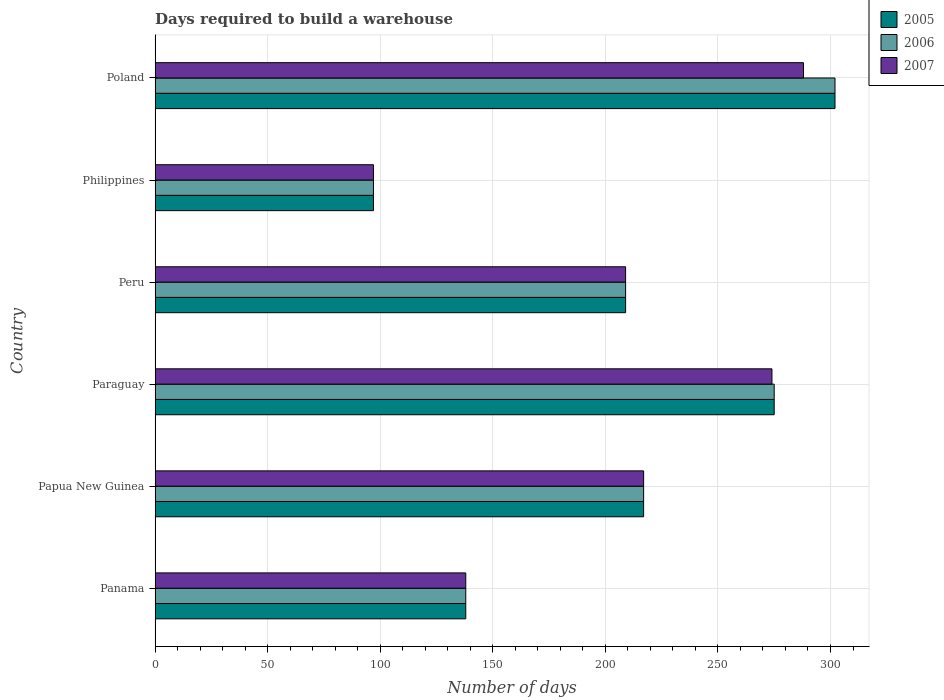How many groups of bars are there?
Your response must be concise. 6. Are the number of bars per tick equal to the number of legend labels?
Provide a short and direct response. Yes. How many bars are there on the 1st tick from the top?
Your response must be concise. 3. How many bars are there on the 4th tick from the bottom?
Keep it short and to the point. 3. In how many cases, is the number of bars for a given country not equal to the number of legend labels?
Provide a succinct answer. 0. What is the days required to build a warehouse in in 2005 in Paraguay?
Provide a short and direct response. 275. Across all countries, what is the maximum days required to build a warehouse in in 2005?
Provide a short and direct response. 302. Across all countries, what is the minimum days required to build a warehouse in in 2005?
Offer a terse response. 97. What is the total days required to build a warehouse in in 2005 in the graph?
Provide a succinct answer. 1238. What is the difference between the days required to build a warehouse in in 2006 in Papua New Guinea and that in Philippines?
Provide a succinct answer. 120. What is the difference between the days required to build a warehouse in in 2007 in Papua New Guinea and the days required to build a warehouse in in 2005 in Paraguay?
Make the answer very short. -58. What is the average days required to build a warehouse in in 2006 per country?
Offer a terse response. 206.33. What is the ratio of the days required to build a warehouse in in 2007 in Panama to that in Papua New Guinea?
Your answer should be very brief. 0.64. Is the days required to build a warehouse in in 2005 in Paraguay less than that in Philippines?
Provide a short and direct response. No. Is the difference between the days required to build a warehouse in in 2007 in Paraguay and Poland greater than the difference between the days required to build a warehouse in in 2006 in Paraguay and Poland?
Offer a very short reply. Yes. What is the difference between the highest and the second highest days required to build a warehouse in in 2007?
Ensure brevity in your answer.  14. What is the difference between the highest and the lowest days required to build a warehouse in in 2006?
Ensure brevity in your answer.  205. In how many countries, is the days required to build a warehouse in in 2005 greater than the average days required to build a warehouse in in 2005 taken over all countries?
Your response must be concise. 4. What does the 3rd bar from the top in Peru represents?
Your answer should be very brief. 2005. How many bars are there?
Give a very brief answer. 18. How many countries are there in the graph?
Offer a terse response. 6. What is the difference between two consecutive major ticks on the X-axis?
Give a very brief answer. 50. Does the graph contain any zero values?
Offer a terse response. No. Where does the legend appear in the graph?
Offer a terse response. Top right. What is the title of the graph?
Provide a short and direct response. Days required to build a warehouse. Does "1982" appear as one of the legend labels in the graph?
Your answer should be very brief. No. What is the label or title of the X-axis?
Offer a very short reply. Number of days. What is the label or title of the Y-axis?
Offer a very short reply. Country. What is the Number of days in 2005 in Panama?
Keep it short and to the point. 138. What is the Number of days in 2006 in Panama?
Make the answer very short. 138. What is the Number of days in 2007 in Panama?
Your answer should be compact. 138. What is the Number of days of 2005 in Papua New Guinea?
Your answer should be compact. 217. What is the Number of days in 2006 in Papua New Guinea?
Your answer should be compact. 217. What is the Number of days in 2007 in Papua New Guinea?
Provide a short and direct response. 217. What is the Number of days in 2005 in Paraguay?
Provide a short and direct response. 275. What is the Number of days of 2006 in Paraguay?
Make the answer very short. 275. What is the Number of days in 2007 in Paraguay?
Keep it short and to the point. 274. What is the Number of days in 2005 in Peru?
Your response must be concise. 209. What is the Number of days of 2006 in Peru?
Your answer should be very brief. 209. What is the Number of days of 2007 in Peru?
Offer a terse response. 209. What is the Number of days of 2005 in Philippines?
Your response must be concise. 97. What is the Number of days in 2006 in Philippines?
Make the answer very short. 97. What is the Number of days of 2007 in Philippines?
Your answer should be very brief. 97. What is the Number of days in 2005 in Poland?
Ensure brevity in your answer.  302. What is the Number of days of 2006 in Poland?
Give a very brief answer. 302. What is the Number of days of 2007 in Poland?
Offer a terse response. 288. Across all countries, what is the maximum Number of days in 2005?
Offer a terse response. 302. Across all countries, what is the maximum Number of days in 2006?
Keep it short and to the point. 302. Across all countries, what is the maximum Number of days of 2007?
Your answer should be compact. 288. Across all countries, what is the minimum Number of days of 2005?
Keep it short and to the point. 97. Across all countries, what is the minimum Number of days of 2006?
Your answer should be very brief. 97. Across all countries, what is the minimum Number of days in 2007?
Your answer should be compact. 97. What is the total Number of days of 2005 in the graph?
Provide a short and direct response. 1238. What is the total Number of days in 2006 in the graph?
Keep it short and to the point. 1238. What is the total Number of days in 2007 in the graph?
Your answer should be very brief. 1223. What is the difference between the Number of days of 2005 in Panama and that in Papua New Guinea?
Your response must be concise. -79. What is the difference between the Number of days of 2006 in Panama and that in Papua New Guinea?
Offer a terse response. -79. What is the difference between the Number of days of 2007 in Panama and that in Papua New Guinea?
Your answer should be compact. -79. What is the difference between the Number of days of 2005 in Panama and that in Paraguay?
Make the answer very short. -137. What is the difference between the Number of days in 2006 in Panama and that in Paraguay?
Provide a succinct answer. -137. What is the difference between the Number of days in 2007 in Panama and that in Paraguay?
Ensure brevity in your answer.  -136. What is the difference between the Number of days of 2005 in Panama and that in Peru?
Make the answer very short. -71. What is the difference between the Number of days of 2006 in Panama and that in Peru?
Provide a succinct answer. -71. What is the difference between the Number of days in 2007 in Panama and that in Peru?
Ensure brevity in your answer.  -71. What is the difference between the Number of days of 2005 in Panama and that in Philippines?
Offer a terse response. 41. What is the difference between the Number of days of 2006 in Panama and that in Philippines?
Ensure brevity in your answer.  41. What is the difference between the Number of days of 2007 in Panama and that in Philippines?
Provide a short and direct response. 41. What is the difference between the Number of days of 2005 in Panama and that in Poland?
Your response must be concise. -164. What is the difference between the Number of days in 2006 in Panama and that in Poland?
Ensure brevity in your answer.  -164. What is the difference between the Number of days in 2007 in Panama and that in Poland?
Ensure brevity in your answer.  -150. What is the difference between the Number of days in 2005 in Papua New Guinea and that in Paraguay?
Make the answer very short. -58. What is the difference between the Number of days of 2006 in Papua New Guinea and that in Paraguay?
Your response must be concise. -58. What is the difference between the Number of days in 2007 in Papua New Guinea and that in Paraguay?
Your answer should be very brief. -57. What is the difference between the Number of days of 2005 in Papua New Guinea and that in Philippines?
Ensure brevity in your answer.  120. What is the difference between the Number of days of 2006 in Papua New Guinea and that in Philippines?
Provide a succinct answer. 120. What is the difference between the Number of days in 2007 in Papua New Guinea and that in Philippines?
Ensure brevity in your answer.  120. What is the difference between the Number of days in 2005 in Papua New Guinea and that in Poland?
Your answer should be very brief. -85. What is the difference between the Number of days in 2006 in Papua New Guinea and that in Poland?
Your answer should be very brief. -85. What is the difference between the Number of days of 2007 in Papua New Guinea and that in Poland?
Ensure brevity in your answer.  -71. What is the difference between the Number of days of 2005 in Paraguay and that in Peru?
Your response must be concise. 66. What is the difference between the Number of days in 2005 in Paraguay and that in Philippines?
Offer a very short reply. 178. What is the difference between the Number of days of 2006 in Paraguay and that in Philippines?
Keep it short and to the point. 178. What is the difference between the Number of days of 2007 in Paraguay and that in Philippines?
Offer a very short reply. 177. What is the difference between the Number of days in 2005 in Peru and that in Philippines?
Make the answer very short. 112. What is the difference between the Number of days in 2006 in Peru and that in Philippines?
Your answer should be very brief. 112. What is the difference between the Number of days in 2007 in Peru and that in Philippines?
Offer a very short reply. 112. What is the difference between the Number of days of 2005 in Peru and that in Poland?
Offer a very short reply. -93. What is the difference between the Number of days in 2006 in Peru and that in Poland?
Your answer should be very brief. -93. What is the difference between the Number of days in 2007 in Peru and that in Poland?
Ensure brevity in your answer.  -79. What is the difference between the Number of days in 2005 in Philippines and that in Poland?
Offer a very short reply. -205. What is the difference between the Number of days of 2006 in Philippines and that in Poland?
Provide a succinct answer. -205. What is the difference between the Number of days in 2007 in Philippines and that in Poland?
Make the answer very short. -191. What is the difference between the Number of days in 2005 in Panama and the Number of days in 2006 in Papua New Guinea?
Your response must be concise. -79. What is the difference between the Number of days of 2005 in Panama and the Number of days of 2007 in Papua New Guinea?
Provide a succinct answer. -79. What is the difference between the Number of days in 2006 in Panama and the Number of days in 2007 in Papua New Guinea?
Your response must be concise. -79. What is the difference between the Number of days of 2005 in Panama and the Number of days of 2006 in Paraguay?
Your answer should be very brief. -137. What is the difference between the Number of days in 2005 in Panama and the Number of days in 2007 in Paraguay?
Ensure brevity in your answer.  -136. What is the difference between the Number of days of 2006 in Panama and the Number of days of 2007 in Paraguay?
Your answer should be very brief. -136. What is the difference between the Number of days in 2005 in Panama and the Number of days in 2006 in Peru?
Provide a succinct answer. -71. What is the difference between the Number of days of 2005 in Panama and the Number of days of 2007 in Peru?
Your answer should be very brief. -71. What is the difference between the Number of days in 2006 in Panama and the Number of days in 2007 in Peru?
Your answer should be compact. -71. What is the difference between the Number of days in 2005 in Panama and the Number of days in 2007 in Philippines?
Give a very brief answer. 41. What is the difference between the Number of days in 2006 in Panama and the Number of days in 2007 in Philippines?
Your answer should be very brief. 41. What is the difference between the Number of days in 2005 in Panama and the Number of days in 2006 in Poland?
Provide a short and direct response. -164. What is the difference between the Number of days in 2005 in Panama and the Number of days in 2007 in Poland?
Your response must be concise. -150. What is the difference between the Number of days of 2006 in Panama and the Number of days of 2007 in Poland?
Give a very brief answer. -150. What is the difference between the Number of days in 2005 in Papua New Guinea and the Number of days in 2006 in Paraguay?
Make the answer very short. -58. What is the difference between the Number of days of 2005 in Papua New Guinea and the Number of days of 2007 in Paraguay?
Your answer should be very brief. -57. What is the difference between the Number of days of 2006 in Papua New Guinea and the Number of days of 2007 in Paraguay?
Offer a very short reply. -57. What is the difference between the Number of days in 2005 in Papua New Guinea and the Number of days in 2007 in Peru?
Your response must be concise. 8. What is the difference between the Number of days of 2006 in Papua New Guinea and the Number of days of 2007 in Peru?
Give a very brief answer. 8. What is the difference between the Number of days of 2005 in Papua New Guinea and the Number of days of 2006 in Philippines?
Give a very brief answer. 120. What is the difference between the Number of days of 2005 in Papua New Guinea and the Number of days of 2007 in Philippines?
Your response must be concise. 120. What is the difference between the Number of days of 2006 in Papua New Guinea and the Number of days of 2007 in Philippines?
Your response must be concise. 120. What is the difference between the Number of days in 2005 in Papua New Guinea and the Number of days in 2006 in Poland?
Provide a succinct answer. -85. What is the difference between the Number of days in 2005 in Papua New Guinea and the Number of days in 2007 in Poland?
Ensure brevity in your answer.  -71. What is the difference between the Number of days in 2006 in Papua New Guinea and the Number of days in 2007 in Poland?
Keep it short and to the point. -71. What is the difference between the Number of days in 2005 in Paraguay and the Number of days in 2006 in Peru?
Offer a terse response. 66. What is the difference between the Number of days of 2005 in Paraguay and the Number of days of 2007 in Peru?
Keep it short and to the point. 66. What is the difference between the Number of days of 2005 in Paraguay and the Number of days of 2006 in Philippines?
Offer a very short reply. 178. What is the difference between the Number of days of 2005 in Paraguay and the Number of days of 2007 in Philippines?
Provide a succinct answer. 178. What is the difference between the Number of days of 2006 in Paraguay and the Number of days of 2007 in Philippines?
Provide a short and direct response. 178. What is the difference between the Number of days in 2006 in Paraguay and the Number of days in 2007 in Poland?
Your response must be concise. -13. What is the difference between the Number of days of 2005 in Peru and the Number of days of 2006 in Philippines?
Ensure brevity in your answer.  112. What is the difference between the Number of days in 2005 in Peru and the Number of days in 2007 in Philippines?
Give a very brief answer. 112. What is the difference between the Number of days in 2006 in Peru and the Number of days in 2007 in Philippines?
Make the answer very short. 112. What is the difference between the Number of days of 2005 in Peru and the Number of days of 2006 in Poland?
Your answer should be very brief. -93. What is the difference between the Number of days in 2005 in Peru and the Number of days in 2007 in Poland?
Your response must be concise. -79. What is the difference between the Number of days of 2006 in Peru and the Number of days of 2007 in Poland?
Provide a short and direct response. -79. What is the difference between the Number of days in 2005 in Philippines and the Number of days in 2006 in Poland?
Provide a short and direct response. -205. What is the difference between the Number of days in 2005 in Philippines and the Number of days in 2007 in Poland?
Your response must be concise. -191. What is the difference between the Number of days in 2006 in Philippines and the Number of days in 2007 in Poland?
Your answer should be compact. -191. What is the average Number of days of 2005 per country?
Offer a terse response. 206.33. What is the average Number of days of 2006 per country?
Your answer should be compact. 206.33. What is the average Number of days of 2007 per country?
Ensure brevity in your answer.  203.83. What is the difference between the Number of days of 2006 and Number of days of 2007 in Panama?
Provide a short and direct response. 0. What is the difference between the Number of days of 2005 and Number of days of 2006 in Papua New Guinea?
Make the answer very short. 0. What is the difference between the Number of days of 2005 and Number of days of 2007 in Papua New Guinea?
Offer a very short reply. 0. What is the difference between the Number of days in 2006 and Number of days in 2007 in Papua New Guinea?
Make the answer very short. 0. What is the difference between the Number of days of 2005 and Number of days of 2006 in Paraguay?
Give a very brief answer. 0. What is the difference between the Number of days of 2005 and Number of days of 2006 in Peru?
Your response must be concise. 0. What is the difference between the Number of days in 2005 and Number of days in 2006 in Philippines?
Your response must be concise. 0. What is the difference between the Number of days of 2006 and Number of days of 2007 in Philippines?
Keep it short and to the point. 0. What is the difference between the Number of days in 2005 and Number of days in 2007 in Poland?
Your answer should be compact. 14. What is the ratio of the Number of days of 2005 in Panama to that in Papua New Guinea?
Keep it short and to the point. 0.64. What is the ratio of the Number of days of 2006 in Panama to that in Papua New Guinea?
Your response must be concise. 0.64. What is the ratio of the Number of days of 2007 in Panama to that in Papua New Guinea?
Your response must be concise. 0.64. What is the ratio of the Number of days of 2005 in Panama to that in Paraguay?
Ensure brevity in your answer.  0.5. What is the ratio of the Number of days of 2006 in Panama to that in Paraguay?
Ensure brevity in your answer.  0.5. What is the ratio of the Number of days in 2007 in Panama to that in Paraguay?
Offer a terse response. 0.5. What is the ratio of the Number of days of 2005 in Panama to that in Peru?
Offer a very short reply. 0.66. What is the ratio of the Number of days in 2006 in Panama to that in Peru?
Make the answer very short. 0.66. What is the ratio of the Number of days in 2007 in Panama to that in Peru?
Keep it short and to the point. 0.66. What is the ratio of the Number of days in 2005 in Panama to that in Philippines?
Your response must be concise. 1.42. What is the ratio of the Number of days in 2006 in Panama to that in Philippines?
Make the answer very short. 1.42. What is the ratio of the Number of days in 2007 in Panama to that in Philippines?
Offer a terse response. 1.42. What is the ratio of the Number of days in 2005 in Panama to that in Poland?
Your answer should be compact. 0.46. What is the ratio of the Number of days of 2006 in Panama to that in Poland?
Provide a succinct answer. 0.46. What is the ratio of the Number of days of 2007 in Panama to that in Poland?
Make the answer very short. 0.48. What is the ratio of the Number of days of 2005 in Papua New Guinea to that in Paraguay?
Offer a terse response. 0.79. What is the ratio of the Number of days in 2006 in Papua New Guinea to that in Paraguay?
Give a very brief answer. 0.79. What is the ratio of the Number of days of 2007 in Papua New Guinea to that in Paraguay?
Offer a terse response. 0.79. What is the ratio of the Number of days of 2005 in Papua New Guinea to that in Peru?
Provide a short and direct response. 1.04. What is the ratio of the Number of days in 2006 in Papua New Guinea to that in Peru?
Provide a short and direct response. 1.04. What is the ratio of the Number of days in 2007 in Papua New Guinea to that in Peru?
Provide a succinct answer. 1.04. What is the ratio of the Number of days of 2005 in Papua New Guinea to that in Philippines?
Your answer should be very brief. 2.24. What is the ratio of the Number of days of 2006 in Papua New Guinea to that in Philippines?
Provide a succinct answer. 2.24. What is the ratio of the Number of days of 2007 in Papua New Guinea to that in Philippines?
Give a very brief answer. 2.24. What is the ratio of the Number of days in 2005 in Papua New Guinea to that in Poland?
Make the answer very short. 0.72. What is the ratio of the Number of days in 2006 in Papua New Guinea to that in Poland?
Keep it short and to the point. 0.72. What is the ratio of the Number of days in 2007 in Papua New Guinea to that in Poland?
Keep it short and to the point. 0.75. What is the ratio of the Number of days of 2005 in Paraguay to that in Peru?
Keep it short and to the point. 1.32. What is the ratio of the Number of days of 2006 in Paraguay to that in Peru?
Provide a succinct answer. 1.32. What is the ratio of the Number of days in 2007 in Paraguay to that in Peru?
Make the answer very short. 1.31. What is the ratio of the Number of days of 2005 in Paraguay to that in Philippines?
Keep it short and to the point. 2.84. What is the ratio of the Number of days of 2006 in Paraguay to that in Philippines?
Offer a very short reply. 2.84. What is the ratio of the Number of days in 2007 in Paraguay to that in Philippines?
Offer a very short reply. 2.82. What is the ratio of the Number of days of 2005 in Paraguay to that in Poland?
Give a very brief answer. 0.91. What is the ratio of the Number of days of 2006 in Paraguay to that in Poland?
Keep it short and to the point. 0.91. What is the ratio of the Number of days in 2007 in Paraguay to that in Poland?
Give a very brief answer. 0.95. What is the ratio of the Number of days in 2005 in Peru to that in Philippines?
Keep it short and to the point. 2.15. What is the ratio of the Number of days of 2006 in Peru to that in Philippines?
Offer a terse response. 2.15. What is the ratio of the Number of days of 2007 in Peru to that in Philippines?
Give a very brief answer. 2.15. What is the ratio of the Number of days of 2005 in Peru to that in Poland?
Keep it short and to the point. 0.69. What is the ratio of the Number of days in 2006 in Peru to that in Poland?
Keep it short and to the point. 0.69. What is the ratio of the Number of days of 2007 in Peru to that in Poland?
Provide a short and direct response. 0.73. What is the ratio of the Number of days in 2005 in Philippines to that in Poland?
Your answer should be compact. 0.32. What is the ratio of the Number of days in 2006 in Philippines to that in Poland?
Your response must be concise. 0.32. What is the ratio of the Number of days in 2007 in Philippines to that in Poland?
Make the answer very short. 0.34. What is the difference between the highest and the second highest Number of days of 2007?
Give a very brief answer. 14. What is the difference between the highest and the lowest Number of days of 2005?
Your answer should be compact. 205. What is the difference between the highest and the lowest Number of days in 2006?
Offer a very short reply. 205. What is the difference between the highest and the lowest Number of days of 2007?
Your response must be concise. 191. 